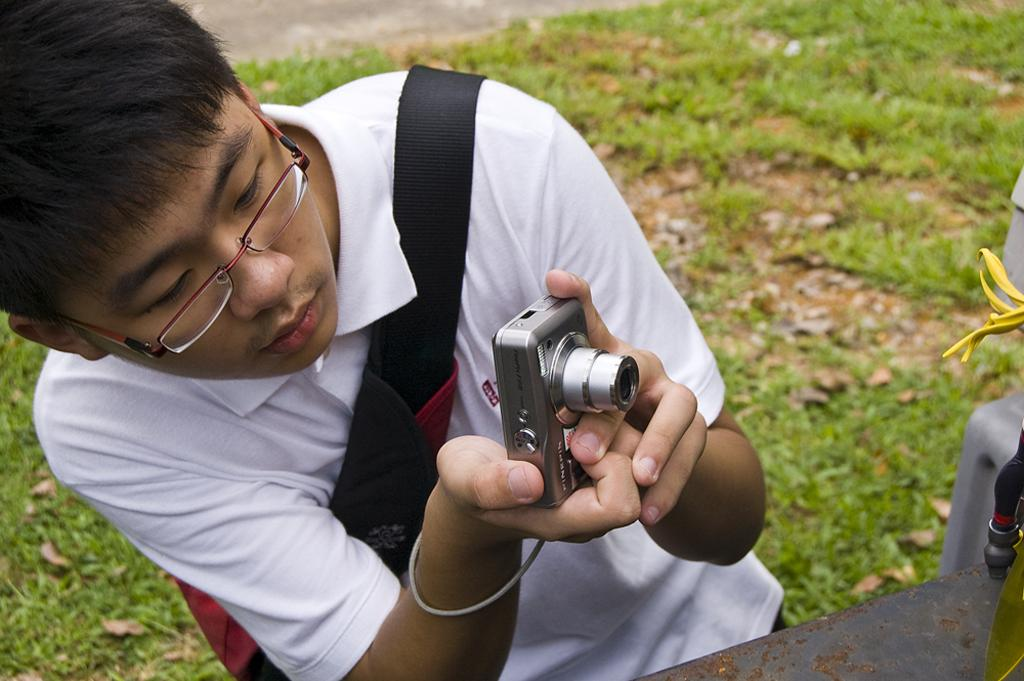Who is the main subject in the image? There is a boy in the image. What is the boy holding in the image? The boy is holding a camera. What is the boy doing with the camera? The boy is taking a picture. What invention is the boy wearing in the image? The boy is not wearing an invention in the image; he is wearing a shirt, which is a common piece of clothing. 